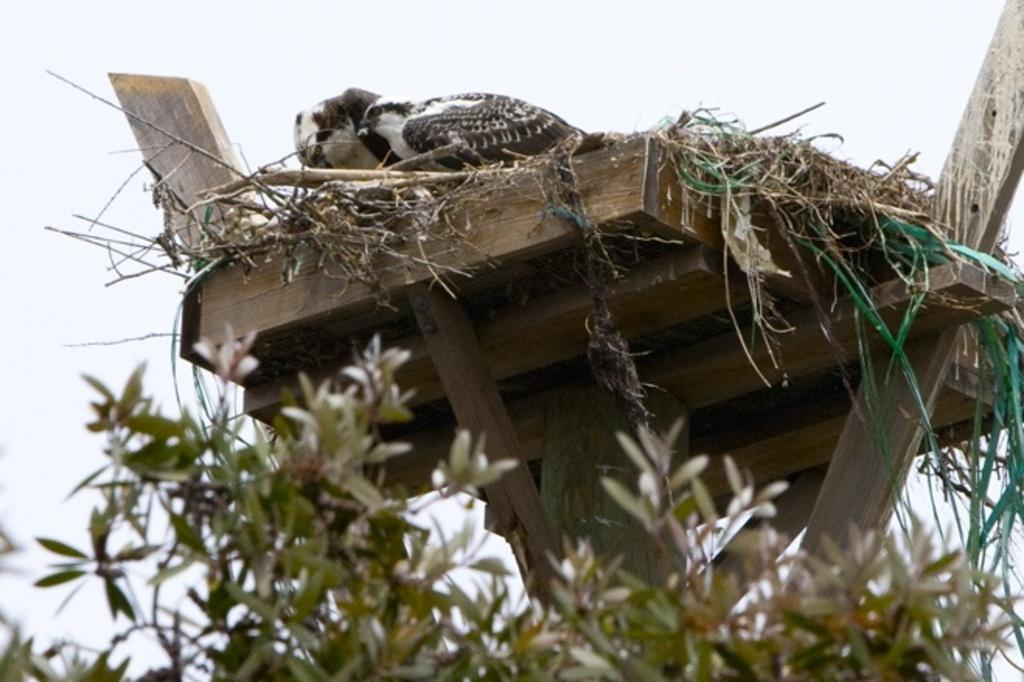What type of living organisms can be seen in the image? Plants are visible in the image. What are the birds perched on in the image? The birds are on a wooden object in the image. What can be seen in the background of the image? The sky is visible in the background of the image. How much sugar is in the wooden object in the image? There is no sugar present in the wooden object or the image. 